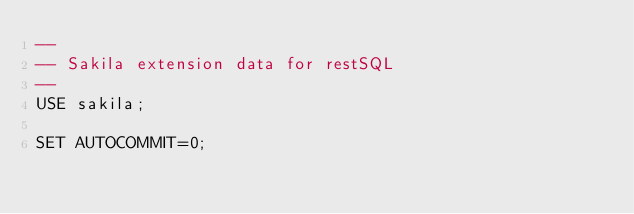<code> <loc_0><loc_0><loc_500><loc_500><_SQL_>--
-- Sakila extension data for restSQL
--
USE sakila;

SET AUTOCOMMIT=0;</code> 